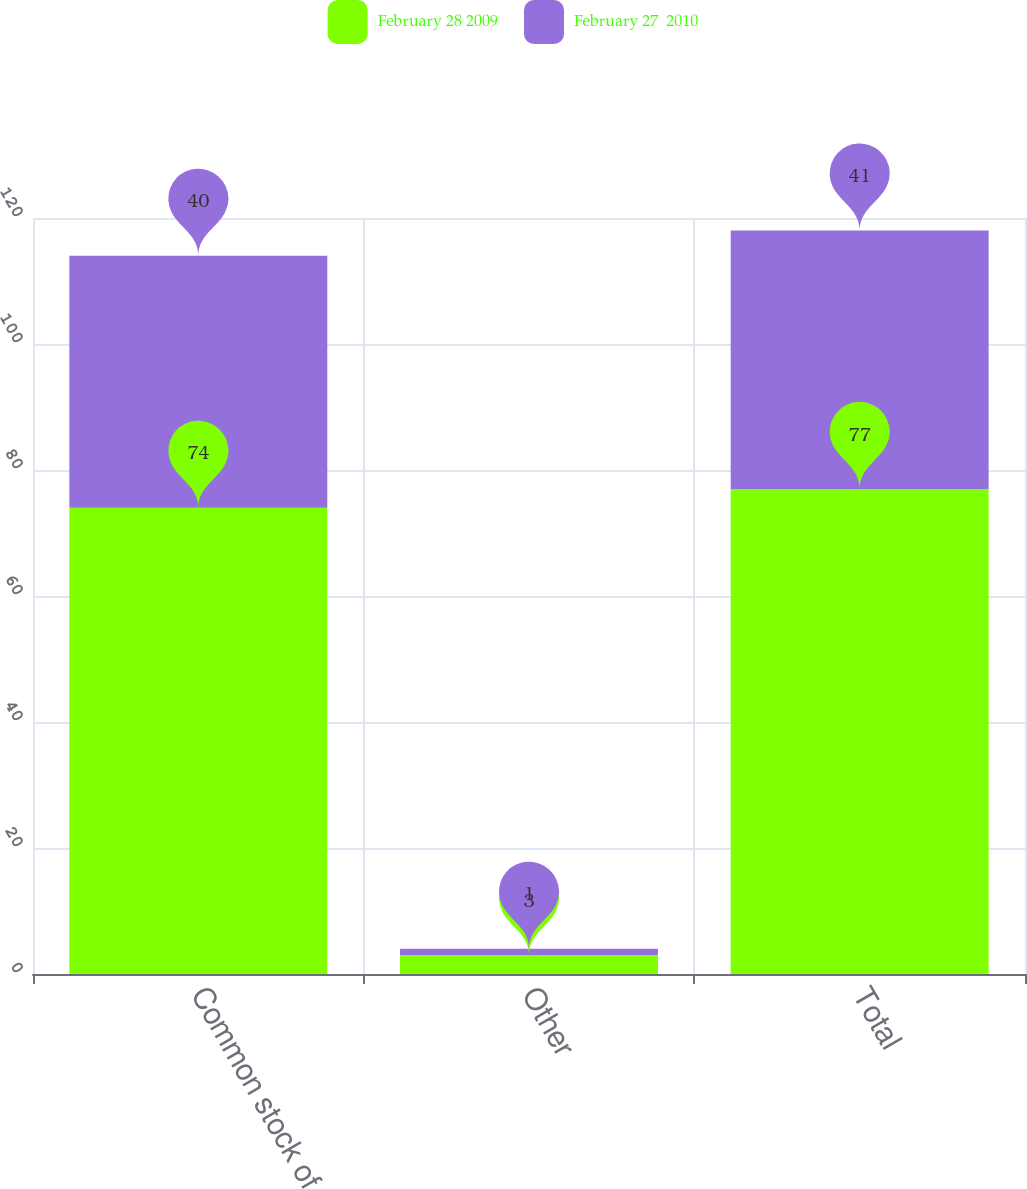Convert chart. <chart><loc_0><loc_0><loc_500><loc_500><stacked_bar_chart><ecel><fcel>Common stock of CPW<fcel>Other<fcel>Total<nl><fcel>February 28 2009<fcel>74<fcel>3<fcel>77<nl><fcel>February 27  2010<fcel>40<fcel>1<fcel>41<nl></chart> 